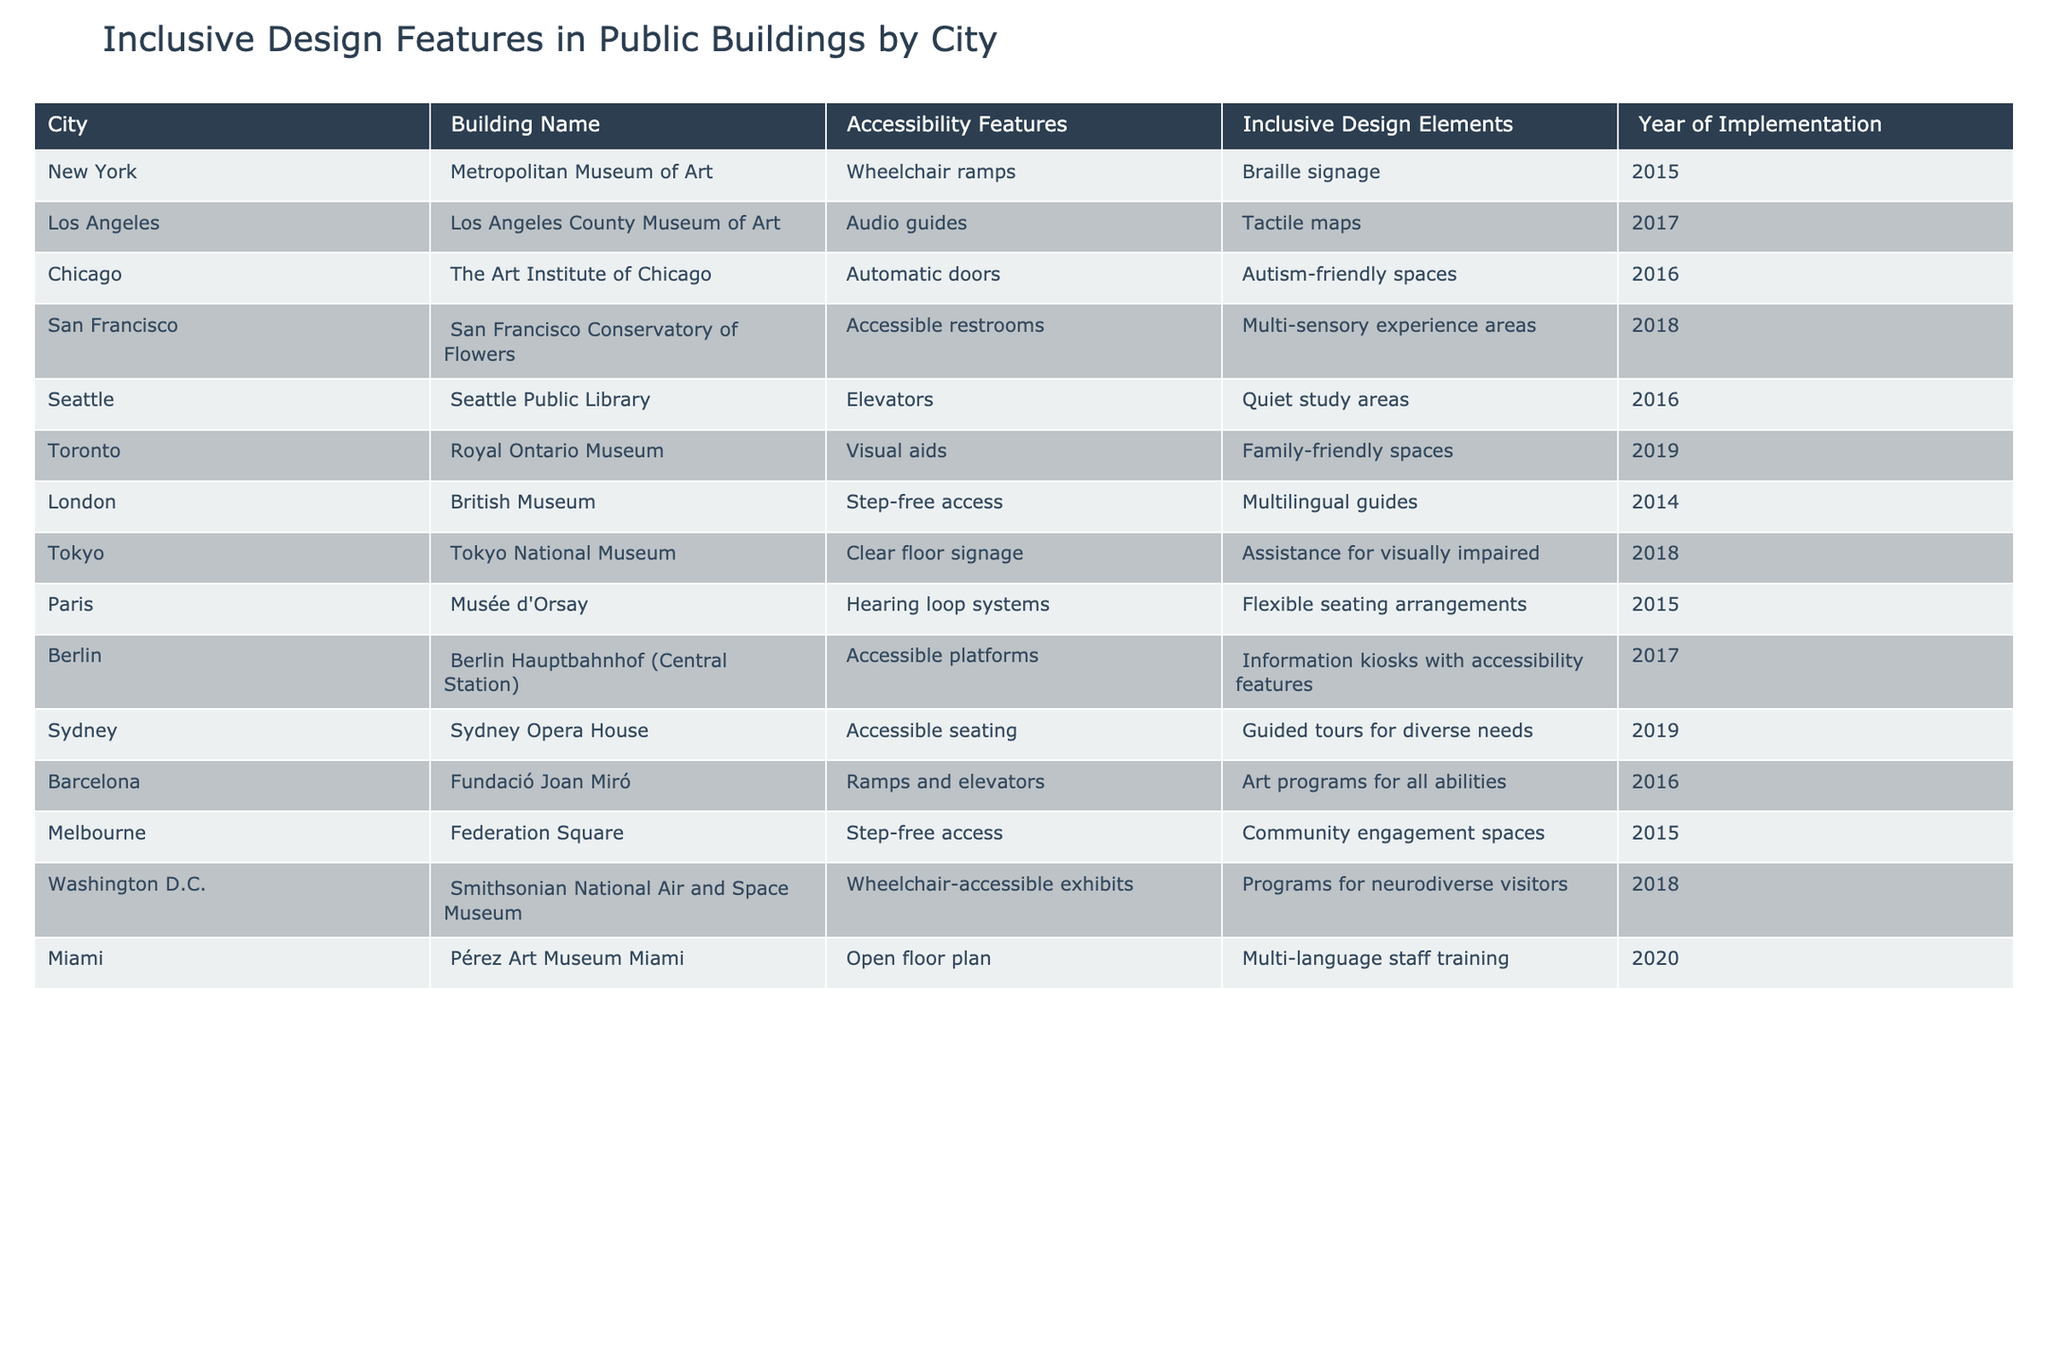What accessibility feature is provided by the Berlin Hauptbahnhof? The table shows that Berlin Hauptbahnhof offers 'Accessible platforms' as its accessibility feature.
Answer: Accessible platforms Which city has the most recent implementation date for inclusive design features? By examining the 'Year of Implementation' column, I can see that Miami, with implementation in 2020, is the most recent.
Answer: 2020 Does the Los Angeles County Museum of Art provide audio guides? According to the table, the Los Angeles County Museum of Art does indeed provide audio guides as an accessibility feature.
Answer: Yes How many cities provide 'accessible seating' as a feature in their public buildings? The table lists 'accessible seating' for Sydney Opera House and identifies it as one of the two cities providing this feature.
Answer: 1 Which city has both 'family-friendly spaces' and a 'multi-language staff training'? The table shows that Toronto's Royal Ontario Museum has 'family-friendly spaces,' and Miami's Pérez Art Museum Miami offers 'multi-language staff training.' No city has both features.
Answer: None What is the average year of implementation for the buildings listed? The implementation years are 2015, 2017, 2016, 2018, 2016, 2019, 2014, 2018, 2015, 2017, 2019, 2015, 2018, 2020. Summing these yields 2017. The average is calculated by dividing by the total number of buildings (14), which results in 2017/14 = approximately 2016.86.
Answer: Approximately 2016.86 Has the British Museum implemented any measures for multilingual guidance? The table indicates that the British Museum has 'Multilingual guides' as an inclusive design element, answering the question affirmatively.
Answer: Yes Which building in Tokyo implements features specifically for the visually impaired? According to the table, the Tokyo National Museum provides 'Assistance for visually impaired' as an inclusive design element dedicated to this demographic.
Answer: Tokyo National Museum 